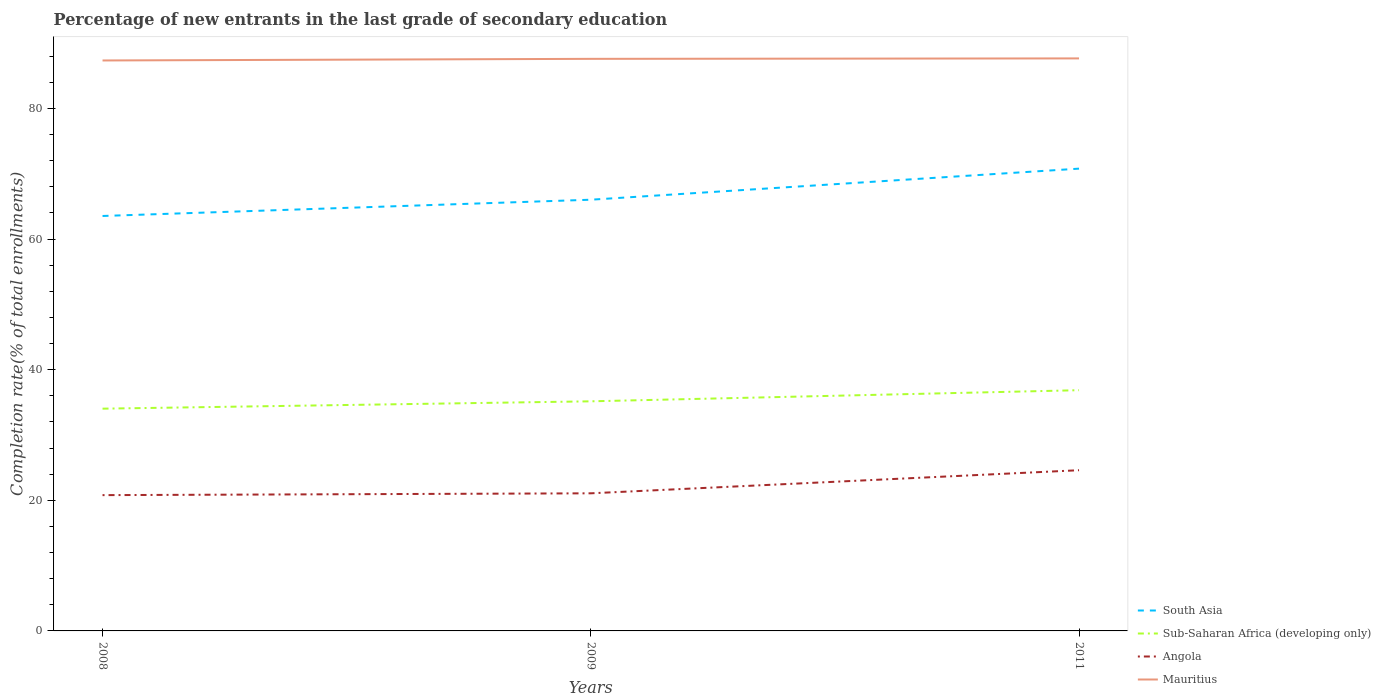How many different coloured lines are there?
Provide a succinct answer. 4. Across all years, what is the maximum percentage of new entrants in Angola?
Give a very brief answer. 20.79. What is the total percentage of new entrants in Sub-Saharan Africa (developing only) in the graph?
Ensure brevity in your answer.  -2.83. What is the difference between the highest and the second highest percentage of new entrants in South Asia?
Give a very brief answer. 7.25. How many years are there in the graph?
Provide a succinct answer. 3. Are the values on the major ticks of Y-axis written in scientific E-notation?
Give a very brief answer. No. Does the graph contain any zero values?
Make the answer very short. No. Where does the legend appear in the graph?
Offer a terse response. Bottom right. How are the legend labels stacked?
Keep it short and to the point. Vertical. What is the title of the graph?
Offer a terse response. Percentage of new entrants in the last grade of secondary education. Does "Bermuda" appear as one of the legend labels in the graph?
Your answer should be very brief. No. What is the label or title of the Y-axis?
Your response must be concise. Completion rate(% of total enrollments). What is the Completion rate(% of total enrollments) of South Asia in 2008?
Your answer should be compact. 63.53. What is the Completion rate(% of total enrollments) in Sub-Saharan Africa (developing only) in 2008?
Your answer should be very brief. 34.03. What is the Completion rate(% of total enrollments) of Angola in 2008?
Make the answer very short. 20.79. What is the Completion rate(% of total enrollments) in Mauritius in 2008?
Make the answer very short. 87.34. What is the Completion rate(% of total enrollments) in South Asia in 2009?
Your answer should be compact. 66.02. What is the Completion rate(% of total enrollments) of Sub-Saharan Africa (developing only) in 2009?
Give a very brief answer. 35.15. What is the Completion rate(% of total enrollments) of Angola in 2009?
Give a very brief answer. 21.07. What is the Completion rate(% of total enrollments) of Mauritius in 2009?
Your answer should be compact. 87.59. What is the Completion rate(% of total enrollments) of South Asia in 2011?
Make the answer very short. 70.78. What is the Completion rate(% of total enrollments) in Sub-Saharan Africa (developing only) in 2011?
Your response must be concise. 36.86. What is the Completion rate(% of total enrollments) of Angola in 2011?
Give a very brief answer. 24.61. What is the Completion rate(% of total enrollments) of Mauritius in 2011?
Provide a short and direct response. 87.66. Across all years, what is the maximum Completion rate(% of total enrollments) in South Asia?
Your response must be concise. 70.78. Across all years, what is the maximum Completion rate(% of total enrollments) of Sub-Saharan Africa (developing only)?
Provide a succinct answer. 36.86. Across all years, what is the maximum Completion rate(% of total enrollments) in Angola?
Make the answer very short. 24.61. Across all years, what is the maximum Completion rate(% of total enrollments) of Mauritius?
Provide a succinct answer. 87.66. Across all years, what is the minimum Completion rate(% of total enrollments) in South Asia?
Provide a succinct answer. 63.53. Across all years, what is the minimum Completion rate(% of total enrollments) in Sub-Saharan Africa (developing only)?
Provide a short and direct response. 34.03. Across all years, what is the minimum Completion rate(% of total enrollments) in Angola?
Your response must be concise. 20.79. Across all years, what is the minimum Completion rate(% of total enrollments) in Mauritius?
Give a very brief answer. 87.34. What is the total Completion rate(% of total enrollments) of South Asia in the graph?
Provide a short and direct response. 200.34. What is the total Completion rate(% of total enrollments) in Sub-Saharan Africa (developing only) in the graph?
Offer a terse response. 106.04. What is the total Completion rate(% of total enrollments) of Angola in the graph?
Make the answer very short. 66.47. What is the total Completion rate(% of total enrollments) of Mauritius in the graph?
Provide a succinct answer. 262.59. What is the difference between the Completion rate(% of total enrollments) in South Asia in 2008 and that in 2009?
Your answer should be very brief. -2.49. What is the difference between the Completion rate(% of total enrollments) of Sub-Saharan Africa (developing only) in 2008 and that in 2009?
Offer a terse response. -1.12. What is the difference between the Completion rate(% of total enrollments) of Angola in 2008 and that in 2009?
Provide a succinct answer. -0.28. What is the difference between the Completion rate(% of total enrollments) in Mauritius in 2008 and that in 2009?
Offer a terse response. -0.25. What is the difference between the Completion rate(% of total enrollments) in South Asia in 2008 and that in 2011?
Give a very brief answer. -7.25. What is the difference between the Completion rate(% of total enrollments) in Sub-Saharan Africa (developing only) in 2008 and that in 2011?
Your answer should be compact. -2.83. What is the difference between the Completion rate(% of total enrollments) in Angola in 2008 and that in 2011?
Offer a very short reply. -3.81. What is the difference between the Completion rate(% of total enrollments) in Mauritius in 2008 and that in 2011?
Offer a very short reply. -0.31. What is the difference between the Completion rate(% of total enrollments) of South Asia in 2009 and that in 2011?
Your answer should be compact. -4.76. What is the difference between the Completion rate(% of total enrollments) in Sub-Saharan Africa (developing only) in 2009 and that in 2011?
Your answer should be compact. -1.7. What is the difference between the Completion rate(% of total enrollments) in Angola in 2009 and that in 2011?
Keep it short and to the point. -3.54. What is the difference between the Completion rate(% of total enrollments) in Mauritius in 2009 and that in 2011?
Provide a succinct answer. -0.07. What is the difference between the Completion rate(% of total enrollments) of South Asia in 2008 and the Completion rate(% of total enrollments) of Sub-Saharan Africa (developing only) in 2009?
Provide a short and direct response. 28.38. What is the difference between the Completion rate(% of total enrollments) of South Asia in 2008 and the Completion rate(% of total enrollments) of Angola in 2009?
Offer a terse response. 42.46. What is the difference between the Completion rate(% of total enrollments) of South Asia in 2008 and the Completion rate(% of total enrollments) of Mauritius in 2009?
Ensure brevity in your answer.  -24.06. What is the difference between the Completion rate(% of total enrollments) of Sub-Saharan Africa (developing only) in 2008 and the Completion rate(% of total enrollments) of Angola in 2009?
Ensure brevity in your answer.  12.96. What is the difference between the Completion rate(% of total enrollments) of Sub-Saharan Africa (developing only) in 2008 and the Completion rate(% of total enrollments) of Mauritius in 2009?
Your response must be concise. -53.56. What is the difference between the Completion rate(% of total enrollments) of Angola in 2008 and the Completion rate(% of total enrollments) of Mauritius in 2009?
Your answer should be compact. -66.8. What is the difference between the Completion rate(% of total enrollments) of South Asia in 2008 and the Completion rate(% of total enrollments) of Sub-Saharan Africa (developing only) in 2011?
Ensure brevity in your answer.  26.67. What is the difference between the Completion rate(% of total enrollments) in South Asia in 2008 and the Completion rate(% of total enrollments) in Angola in 2011?
Give a very brief answer. 38.93. What is the difference between the Completion rate(% of total enrollments) of South Asia in 2008 and the Completion rate(% of total enrollments) of Mauritius in 2011?
Offer a very short reply. -24.13. What is the difference between the Completion rate(% of total enrollments) in Sub-Saharan Africa (developing only) in 2008 and the Completion rate(% of total enrollments) in Angola in 2011?
Your answer should be very brief. 9.42. What is the difference between the Completion rate(% of total enrollments) of Sub-Saharan Africa (developing only) in 2008 and the Completion rate(% of total enrollments) of Mauritius in 2011?
Keep it short and to the point. -53.63. What is the difference between the Completion rate(% of total enrollments) in Angola in 2008 and the Completion rate(% of total enrollments) in Mauritius in 2011?
Give a very brief answer. -66.87. What is the difference between the Completion rate(% of total enrollments) of South Asia in 2009 and the Completion rate(% of total enrollments) of Sub-Saharan Africa (developing only) in 2011?
Offer a very short reply. 29.17. What is the difference between the Completion rate(% of total enrollments) of South Asia in 2009 and the Completion rate(% of total enrollments) of Angola in 2011?
Your answer should be very brief. 41.42. What is the difference between the Completion rate(% of total enrollments) of South Asia in 2009 and the Completion rate(% of total enrollments) of Mauritius in 2011?
Provide a short and direct response. -21.63. What is the difference between the Completion rate(% of total enrollments) of Sub-Saharan Africa (developing only) in 2009 and the Completion rate(% of total enrollments) of Angola in 2011?
Your answer should be compact. 10.55. What is the difference between the Completion rate(% of total enrollments) of Sub-Saharan Africa (developing only) in 2009 and the Completion rate(% of total enrollments) of Mauritius in 2011?
Ensure brevity in your answer.  -52.5. What is the difference between the Completion rate(% of total enrollments) in Angola in 2009 and the Completion rate(% of total enrollments) in Mauritius in 2011?
Your response must be concise. -66.59. What is the average Completion rate(% of total enrollments) in South Asia per year?
Keep it short and to the point. 66.78. What is the average Completion rate(% of total enrollments) of Sub-Saharan Africa (developing only) per year?
Provide a succinct answer. 35.35. What is the average Completion rate(% of total enrollments) in Angola per year?
Provide a short and direct response. 22.16. What is the average Completion rate(% of total enrollments) of Mauritius per year?
Give a very brief answer. 87.53. In the year 2008, what is the difference between the Completion rate(% of total enrollments) in South Asia and Completion rate(% of total enrollments) in Sub-Saharan Africa (developing only)?
Your response must be concise. 29.5. In the year 2008, what is the difference between the Completion rate(% of total enrollments) of South Asia and Completion rate(% of total enrollments) of Angola?
Provide a short and direct response. 42.74. In the year 2008, what is the difference between the Completion rate(% of total enrollments) of South Asia and Completion rate(% of total enrollments) of Mauritius?
Offer a terse response. -23.81. In the year 2008, what is the difference between the Completion rate(% of total enrollments) in Sub-Saharan Africa (developing only) and Completion rate(% of total enrollments) in Angola?
Offer a very short reply. 13.24. In the year 2008, what is the difference between the Completion rate(% of total enrollments) in Sub-Saharan Africa (developing only) and Completion rate(% of total enrollments) in Mauritius?
Provide a short and direct response. -53.31. In the year 2008, what is the difference between the Completion rate(% of total enrollments) of Angola and Completion rate(% of total enrollments) of Mauritius?
Your answer should be very brief. -66.55. In the year 2009, what is the difference between the Completion rate(% of total enrollments) of South Asia and Completion rate(% of total enrollments) of Sub-Saharan Africa (developing only)?
Your answer should be very brief. 30.87. In the year 2009, what is the difference between the Completion rate(% of total enrollments) in South Asia and Completion rate(% of total enrollments) in Angola?
Offer a terse response. 44.95. In the year 2009, what is the difference between the Completion rate(% of total enrollments) in South Asia and Completion rate(% of total enrollments) in Mauritius?
Make the answer very short. -21.57. In the year 2009, what is the difference between the Completion rate(% of total enrollments) of Sub-Saharan Africa (developing only) and Completion rate(% of total enrollments) of Angola?
Provide a succinct answer. 14.09. In the year 2009, what is the difference between the Completion rate(% of total enrollments) of Sub-Saharan Africa (developing only) and Completion rate(% of total enrollments) of Mauritius?
Ensure brevity in your answer.  -52.44. In the year 2009, what is the difference between the Completion rate(% of total enrollments) of Angola and Completion rate(% of total enrollments) of Mauritius?
Your answer should be compact. -66.52. In the year 2011, what is the difference between the Completion rate(% of total enrollments) of South Asia and Completion rate(% of total enrollments) of Sub-Saharan Africa (developing only)?
Give a very brief answer. 33.92. In the year 2011, what is the difference between the Completion rate(% of total enrollments) in South Asia and Completion rate(% of total enrollments) in Angola?
Give a very brief answer. 46.17. In the year 2011, what is the difference between the Completion rate(% of total enrollments) of South Asia and Completion rate(% of total enrollments) of Mauritius?
Ensure brevity in your answer.  -16.88. In the year 2011, what is the difference between the Completion rate(% of total enrollments) of Sub-Saharan Africa (developing only) and Completion rate(% of total enrollments) of Angola?
Keep it short and to the point. 12.25. In the year 2011, what is the difference between the Completion rate(% of total enrollments) in Sub-Saharan Africa (developing only) and Completion rate(% of total enrollments) in Mauritius?
Your response must be concise. -50.8. In the year 2011, what is the difference between the Completion rate(% of total enrollments) in Angola and Completion rate(% of total enrollments) in Mauritius?
Keep it short and to the point. -63.05. What is the ratio of the Completion rate(% of total enrollments) in South Asia in 2008 to that in 2009?
Your response must be concise. 0.96. What is the ratio of the Completion rate(% of total enrollments) in Sub-Saharan Africa (developing only) in 2008 to that in 2009?
Ensure brevity in your answer.  0.97. What is the ratio of the Completion rate(% of total enrollments) in South Asia in 2008 to that in 2011?
Keep it short and to the point. 0.9. What is the ratio of the Completion rate(% of total enrollments) of Sub-Saharan Africa (developing only) in 2008 to that in 2011?
Provide a succinct answer. 0.92. What is the ratio of the Completion rate(% of total enrollments) in Angola in 2008 to that in 2011?
Keep it short and to the point. 0.84. What is the ratio of the Completion rate(% of total enrollments) in South Asia in 2009 to that in 2011?
Offer a terse response. 0.93. What is the ratio of the Completion rate(% of total enrollments) of Sub-Saharan Africa (developing only) in 2009 to that in 2011?
Give a very brief answer. 0.95. What is the ratio of the Completion rate(% of total enrollments) in Angola in 2009 to that in 2011?
Your response must be concise. 0.86. What is the difference between the highest and the second highest Completion rate(% of total enrollments) in South Asia?
Your answer should be very brief. 4.76. What is the difference between the highest and the second highest Completion rate(% of total enrollments) of Sub-Saharan Africa (developing only)?
Your response must be concise. 1.7. What is the difference between the highest and the second highest Completion rate(% of total enrollments) of Angola?
Make the answer very short. 3.54. What is the difference between the highest and the second highest Completion rate(% of total enrollments) in Mauritius?
Your answer should be compact. 0.07. What is the difference between the highest and the lowest Completion rate(% of total enrollments) in South Asia?
Offer a very short reply. 7.25. What is the difference between the highest and the lowest Completion rate(% of total enrollments) of Sub-Saharan Africa (developing only)?
Keep it short and to the point. 2.83. What is the difference between the highest and the lowest Completion rate(% of total enrollments) of Angola?
Your answer should be compact. 3.81. What is the difference between the highest and the lowest Completion rate(% of total enrollments) in Mauritius?
Your response must be concise. 0.31. 